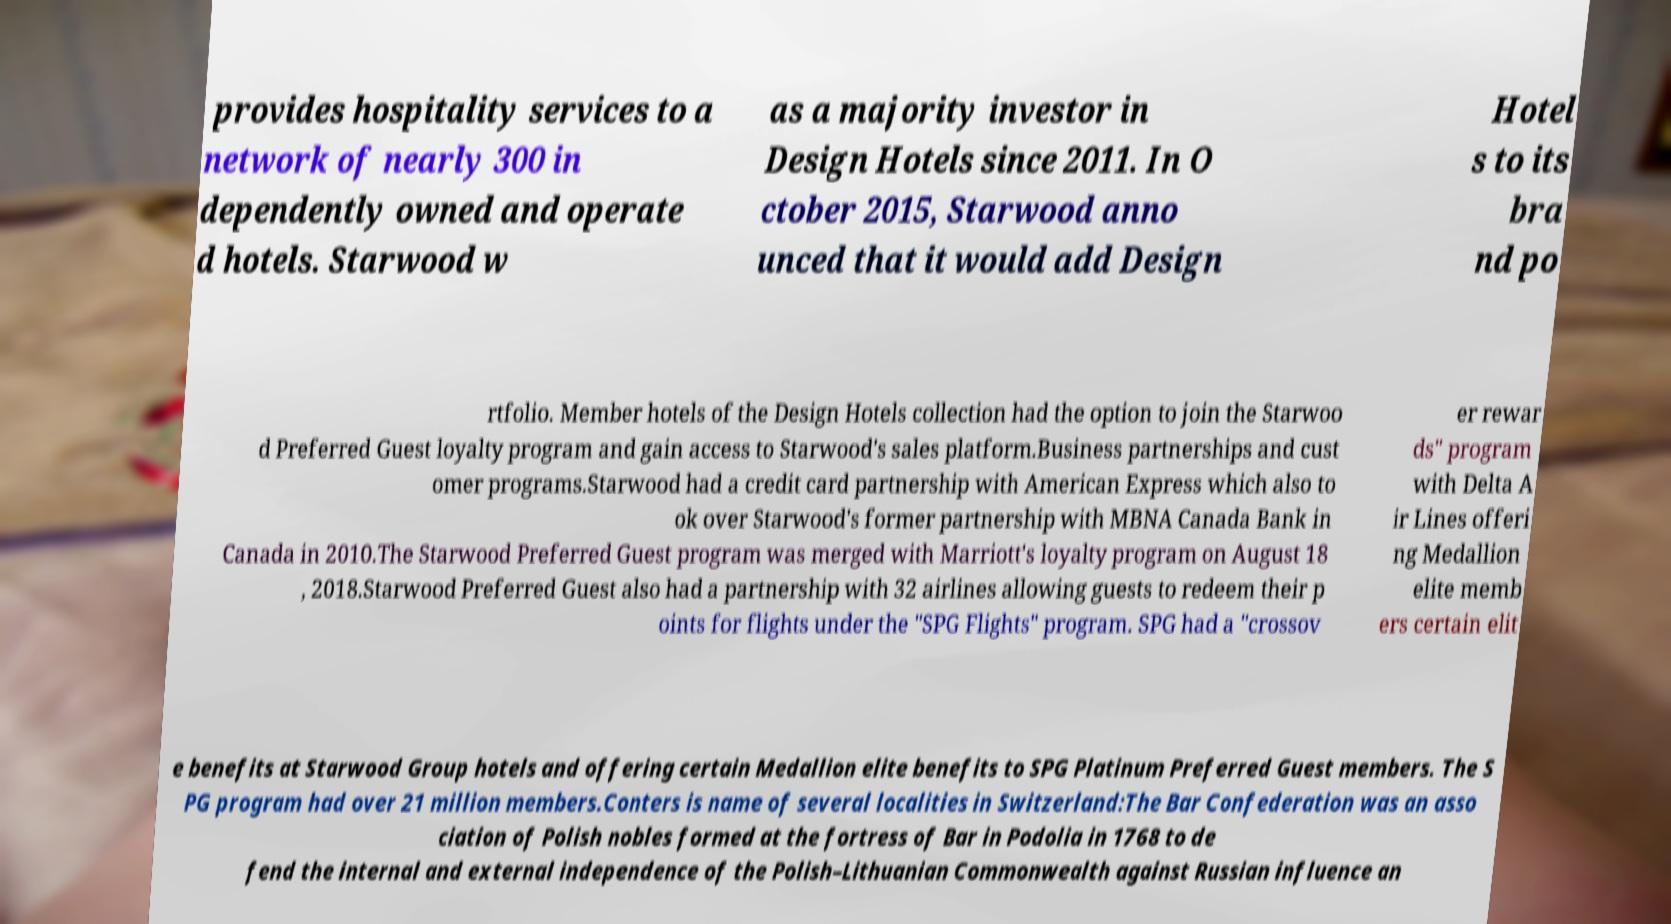For documentation purposes, I need the text within this image transcribed. Could you provide that? provides hospitality services to a network of nearly 300 in dependently owned and operate d hotels. Starwood w as a majority investor in Design Hotels since 2011. In O ctober 2015, Starwood anno unced that it would add Design Hotel s to its bra nd po rtfolio. Member hotels of the Design Hotels collection had the option to join the Starwoo d Preferred Guest loyalty program and gain access to Starwood's sales platform.Business partnerships and cust omer programs.Starwood had a credit card partnership with American Express which also to ok over Starwood's former partnership with MBNA Canada Bank in Canada in 2010.The Starwood Preferred Guest program was merged with Marriott's loyalty program on August 18 , 2018.Starwood Preferred Guest also had a partnership with 32 airlines allowing guests to redeem their p oints for flights under the "SPG Flights" program. SPG had a "crossov er rewar ds" program with Delta A ir Lines offeri ng Medallion elite memb ers certain elit e benefits at Starwood Group hotels and offering certain Medallion elite benefits to SPG Platinum Preferred Guest members. The S PG program had over 21 million members.Conters is name of several localities in Switzerland:The Bar Confederation was an asso ciation of Polish nobles formed at the fortress of Bar in Podolia in 1768 to de fend the internal and external independence of the Polish–Lithuanian Commonwealth against Russian influence an 